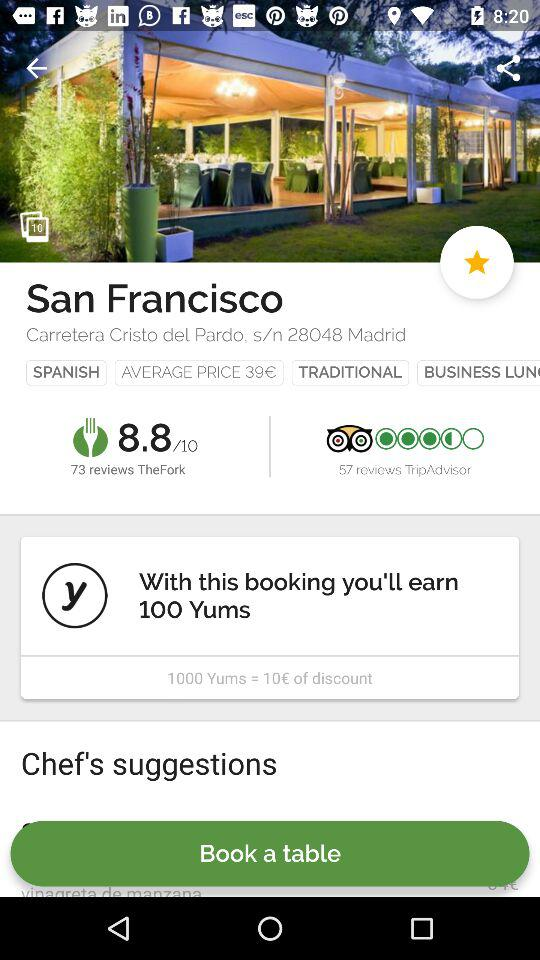How many Yums will I earn if I book a table?
Answer the question using a single word or phrase. 100 